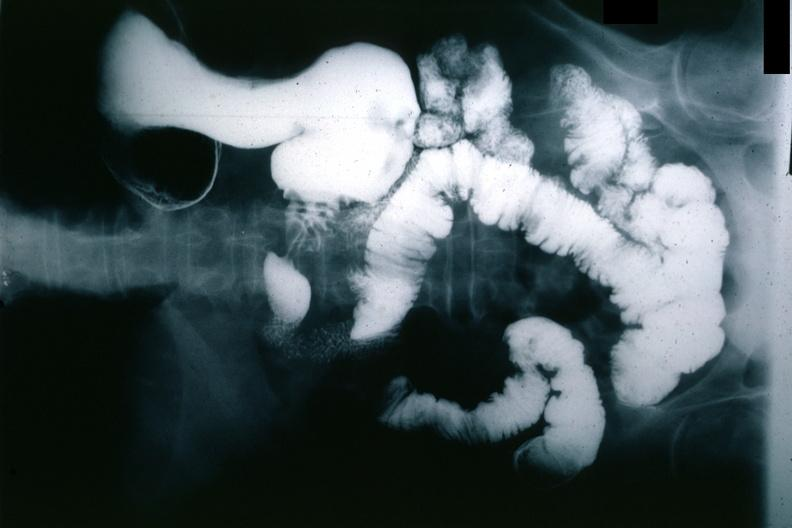does this image show x-ray barium study gastric polyp?
Answer the question using a single word or phrase. Yes 